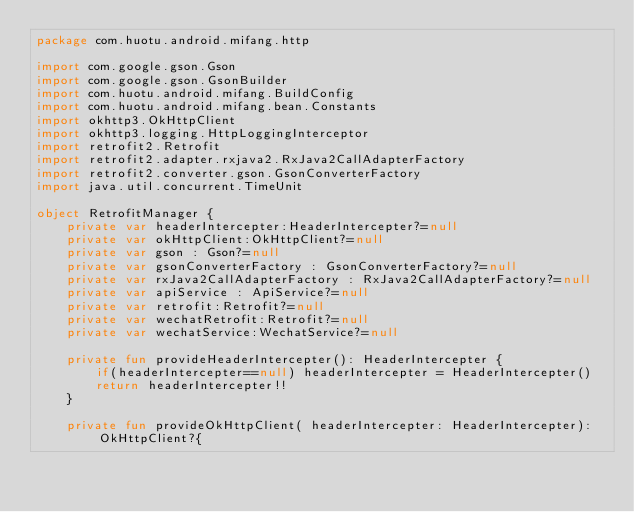Convert code to text. <code><loc_0><loc_0><loc_500><loc_500><_Kotlin_>package com.huotu.android.mifang.http

import com.google.gson.Gson
import com.google.gson.GsonBuilder
import com.huotu.android.mifang.BuildConfig
import com.huotu.android.mifang.bean.Constants
import okhttp3.OkHttpClient
import okhttp3.logging.HttpLoggingInterceptor
import retrofit2.Retrofit
import retrofit2.adapter.rxjava2.RxJava2CallAdapterFactory
import retrofit2.converter.gson.GsonConverterFactory
import java.util.concurrent.TimeUnit

object RetrofitManager {
    private var headerIntercepter:HeaderIntercepter?=null
    private var okHttpClient:OkHttpClient?=null
    private var gson : Gson?=null
    private var gsonConverterFactory : GsonConverterFactory?=null
    private var rxJava2CallAdapterFactory : RxJava2CallAdapterFactory?=null
    private var apiService : ApiService?=null
    private var retrofit:Retrofit?=null
    private var wechatRetrofit:Retrofit?=null
    private var wechatService:WechatService?=null

    private fun provideHeaderIntercepter(): HeaderIntercepter {
        if(headerIntercepter==null) headerIntercepter = HeaderIntercepter()
        return headerIntercepter!!
    }

    private fun provideOkHttpClient( headerIntercepter: HeaderIntercepter):OkHttpClient?{
</code> 